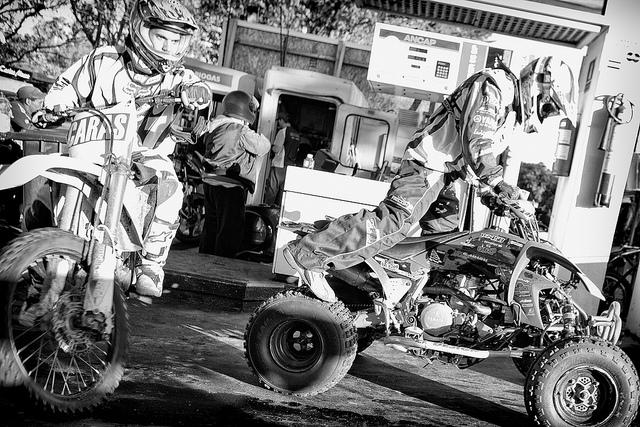What is the man on the right riding? atv 